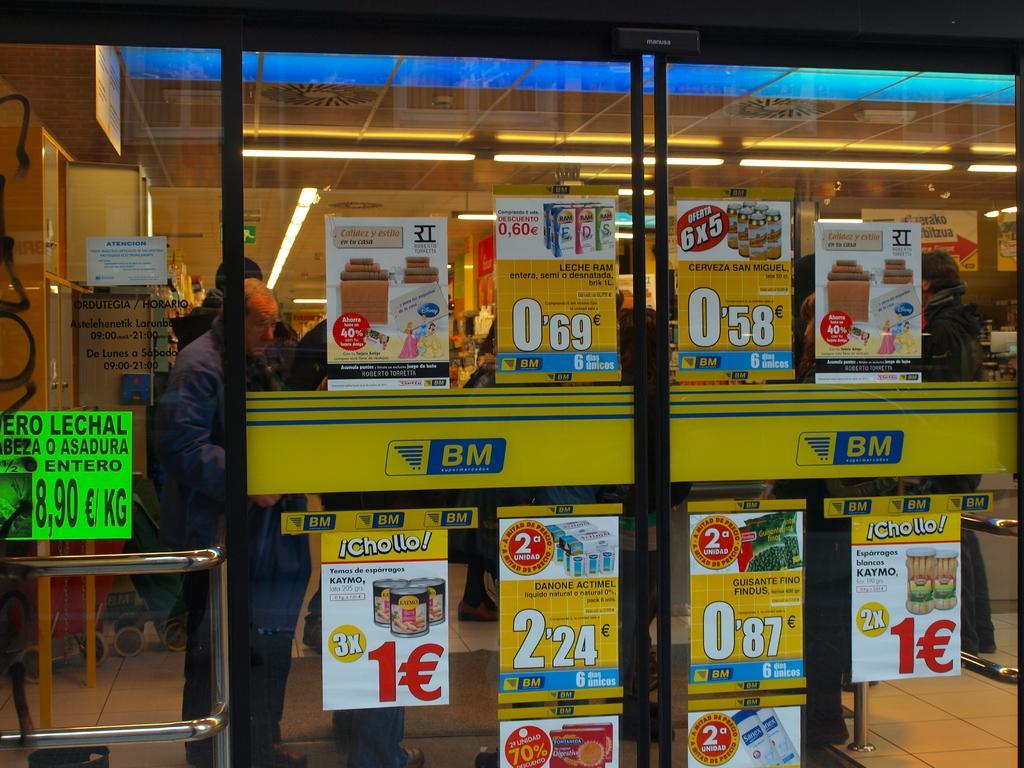Please provide a concise description of this image. In the picture we can see a supermarket with a glass and inside it we can see a man standing and we can also see an item placed in the racks and in the glass we can see some posts are posted and to the ceiling we can see some lights. 